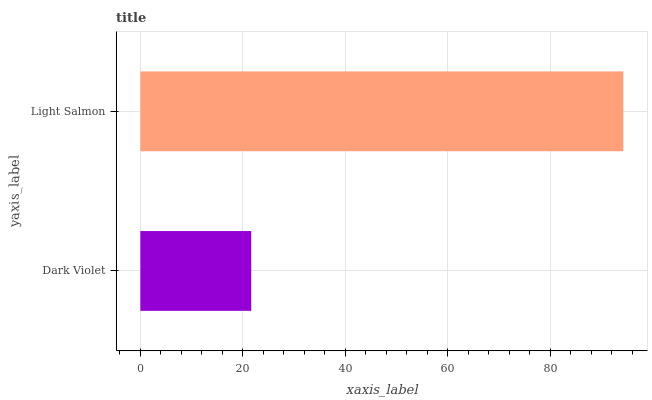Is Dark Violet the minimum?
Answer yes or no. Yes. Is Light Salmon the maximum?
Answer yes or no. Yes. Is Light Salmon the minimum?
Answer yes or no. No. Is Light Salmon greater than Dark Violet?
Answer yes or no. Yes. Is Dark Violet less than Light Salmon?
Answer yes or no. Yes. Is Dark Violet greater than Light Salmon?
Answer yes or no. No. Is Light Salmon less than Dark Violet?
Answer yes or no. No. Is Light Salmon the high median?
Answer yes or no. Yes. Is Dark Violet the low median?
Answer yes or no. Yes. Is Dark Violet the high median?
Answer yes or no. No. Is Light Salmon the low median?
Answer yes or no. No. 